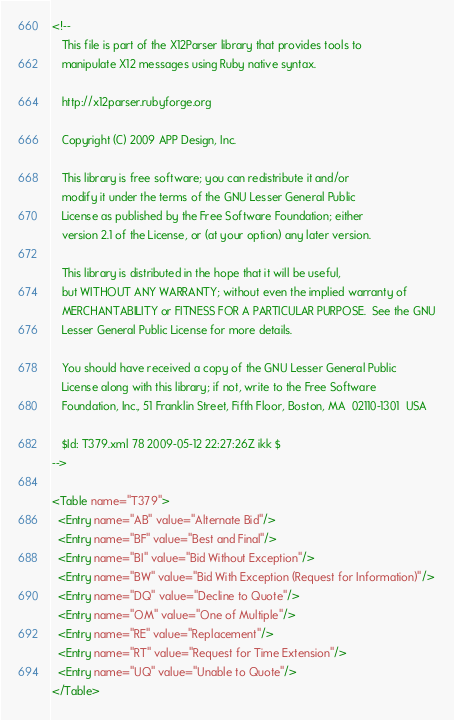Convert code to text. <code><loc_0><loc_0><loc_500><loc_500><_XML_><!--
   This file is part of the X12Parser library that provides tools to
   manipulate X12 messages using Ruby native syntax.

   http://x12parser.rubyforge.org 
   
   Copyright (C) 2009 APP Design, Inc.

   This library is free software; you can redistribute it and/or
   modify it under the terms of the GNU Lesser General Public
   License as published by the Free Software Foundation; either
   version 2.1 of the License, or (at your option) any later version.

   This library is distributed in the hope that it will be useful,
   but WITHOUT ANY WARRANTY; without even the implied warranty of
   MERCHANTABILITY or FITNESS FOR A PARTICULAR PURPOSE.  See the GNU
   Lesser General Public License for more details.

   You should have received a copy of the GNU Lesser General Public
   License along with this library; if not, write to the Free Software
   Foundation, Inc., 51 Franklin Street, Fifth Floor, Boston, MA  02110-1301  USA

   $Id: T379.xml 78 2009-05-12 22:27:26Z ikk $
-->

<Table name="T379">
  <Entry name="AB" value="Alternate Bid"/>
  <Entry name="BF" value="Best and Final"/>
  <Entry name="BI" value="Bid Without Exception"/>
  <Entry name="BW" value="Bid With Exception (Request for Information)"/>
  <Entry name="DQ" value="Decline to Quote"/>
  <Entry name="OM" value="One of Multiple"/>
  <Entry name="RE" value="Replacement"/>
  <Entry name="RT" value="Request for Time Extension"/>
  <Entry name="UQ" value="Unable to Quote"/>
</Table>
</code> 